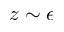<formula> <loc_0><loc_0><loc_500><loc_500>z \sim \epsilon</formula> 